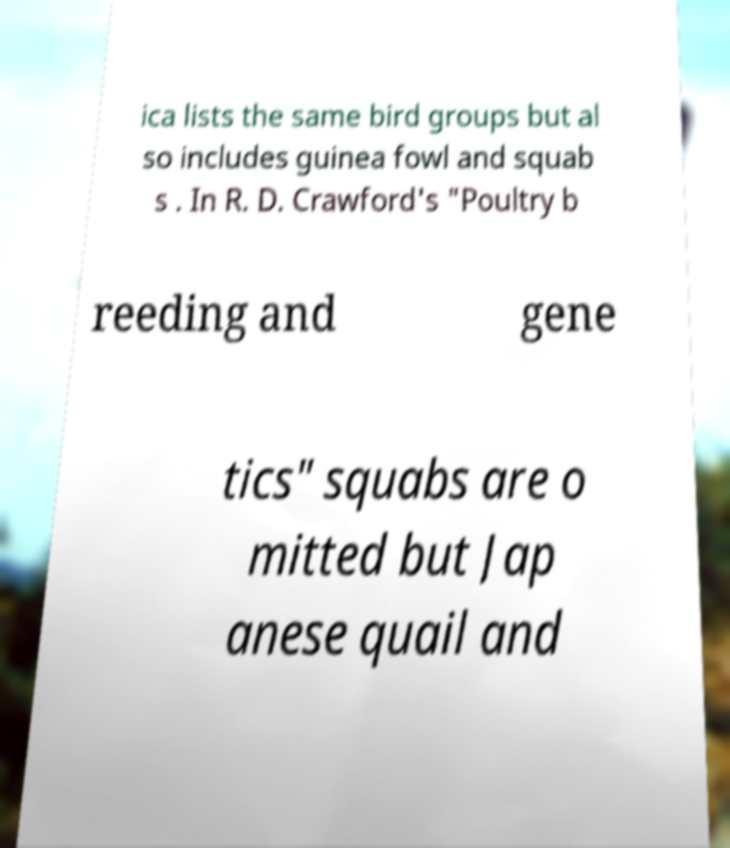Please read and relay the text visible in this image. What does it say? ica lists the same bird groups but al so includes guinea fowl and squab s . In R. D. Crawford's "Poultry b reeding and gene tics" squabs are o mitted but Jap anese quail and 